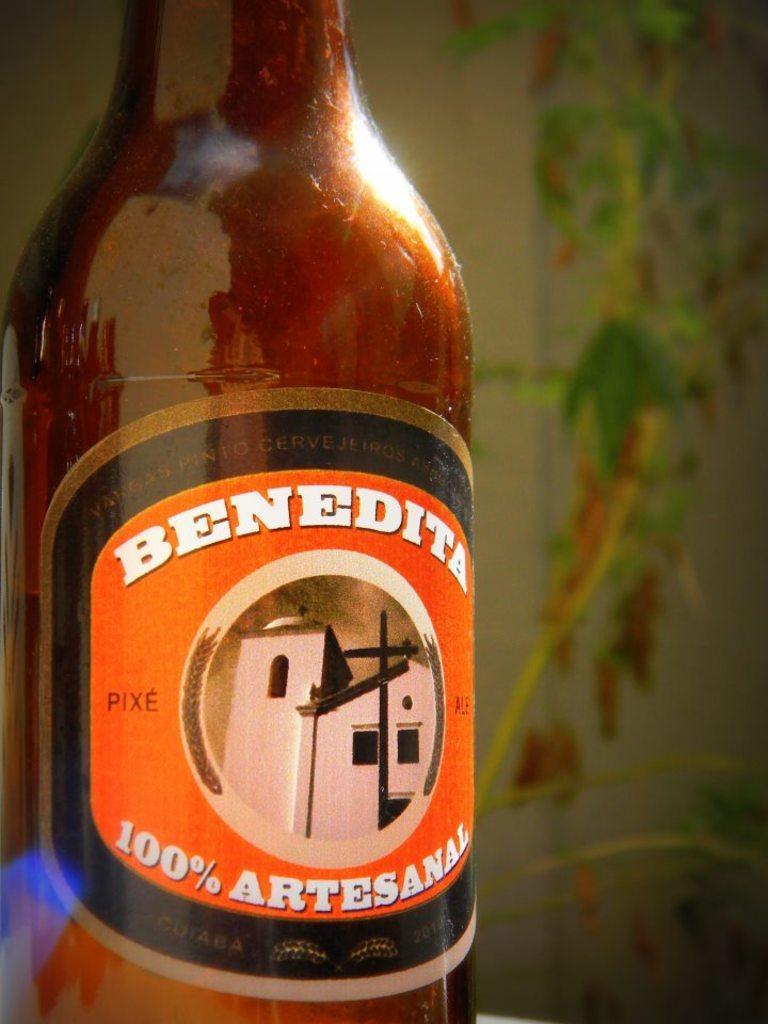In one or two sentences, can you explain what this image depicts? In this image we can see a bottle with one striker attached to it. 